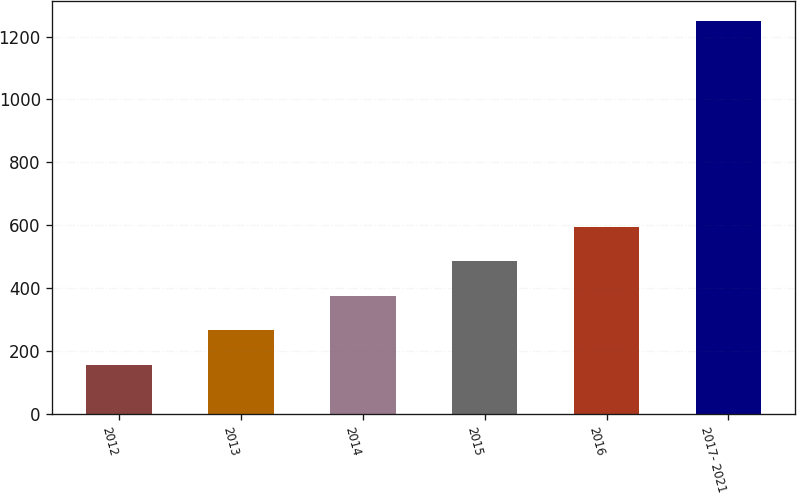Convert chart. <chart><loc_0><loc_0><loc_500><loc_500><bar_chart><fcel>2012<fcel>2013<fcel>2014<fcel>2015<fcel>2016<fcel>2017- 2021<nl><fcel>156<fcel>265.4<fcel>374.8<fcel>484.2<fcel>593.6<fcel>1250<nl></chart> 